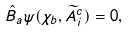Convert formula to latex. <formula><loc_0><loc_0><loc_500><loc_500>\hat { B } _ { a } \psi ( \chi _ { b } , \widetilde { A } ^ { c } _ { i } ) = 0 ,</formula> 